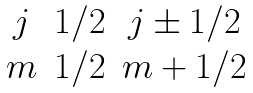Convert formula to latex. <formula><loc_0><loc_0><loc_500><loc_500>\begin{matrix} j & 1 / 2 & j \pm 1 / 2 \\ m & 1 / 2 & m + 1 / 2 \end{matrix}</formula> 